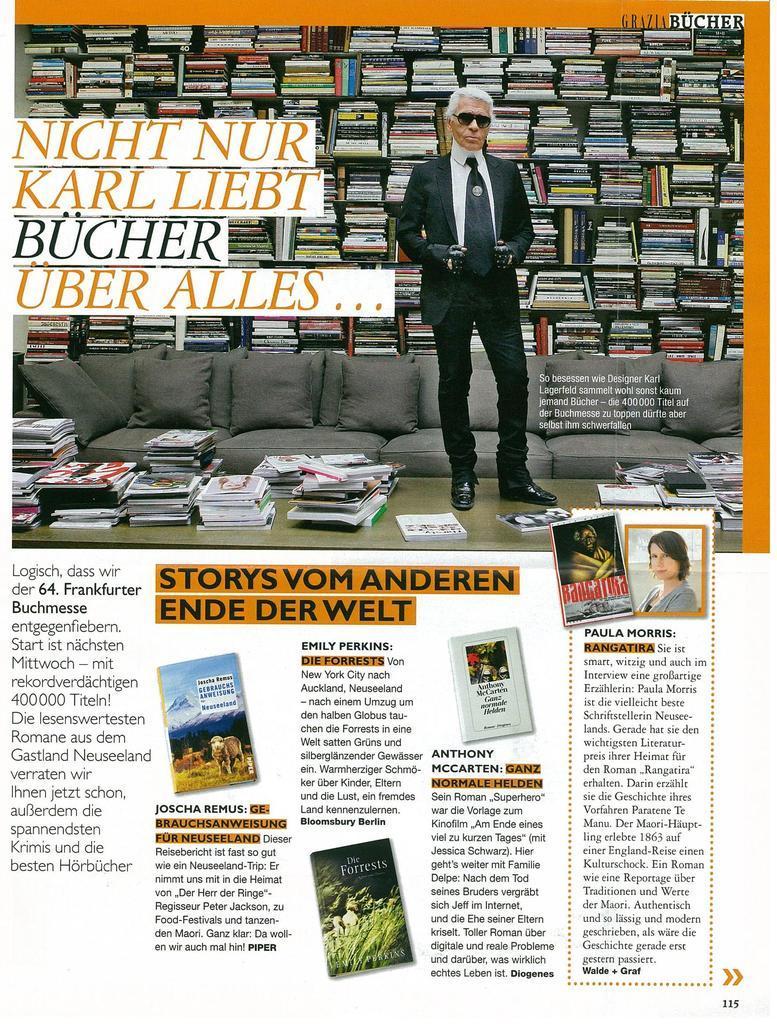In one or two sentences, can you explain what this image depicts? In this image I can see an article where on the top side I can see a picture and on the bottom side I can see something is written. In this picture I can see a man is standing and behind him I can see a sofa. On the sofa I can see few cushions. I can also see number of books in this picture. 